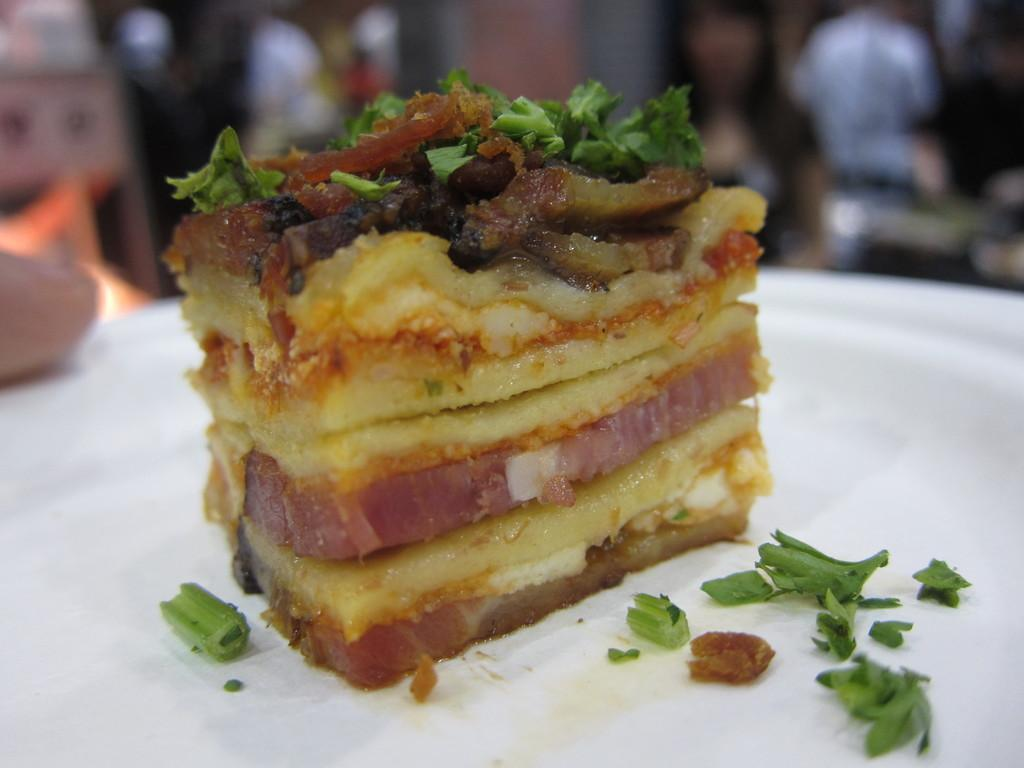What object is present on the plate in the image? There is a food item on the plate in the image. Can you describe the food item on the plate? Unfortunately, the facts provided do not specify the type of food on the plate. Are there any people visible in the image? Yes, there are persons visible in the background of the image, although they are blurry. What is the caption of the image? There is no caption present in the image. What type of bread can be seen on the plate in the image? The facts provided do not mention any bread on the plate, so we cannot determine the type of bread from the image. 